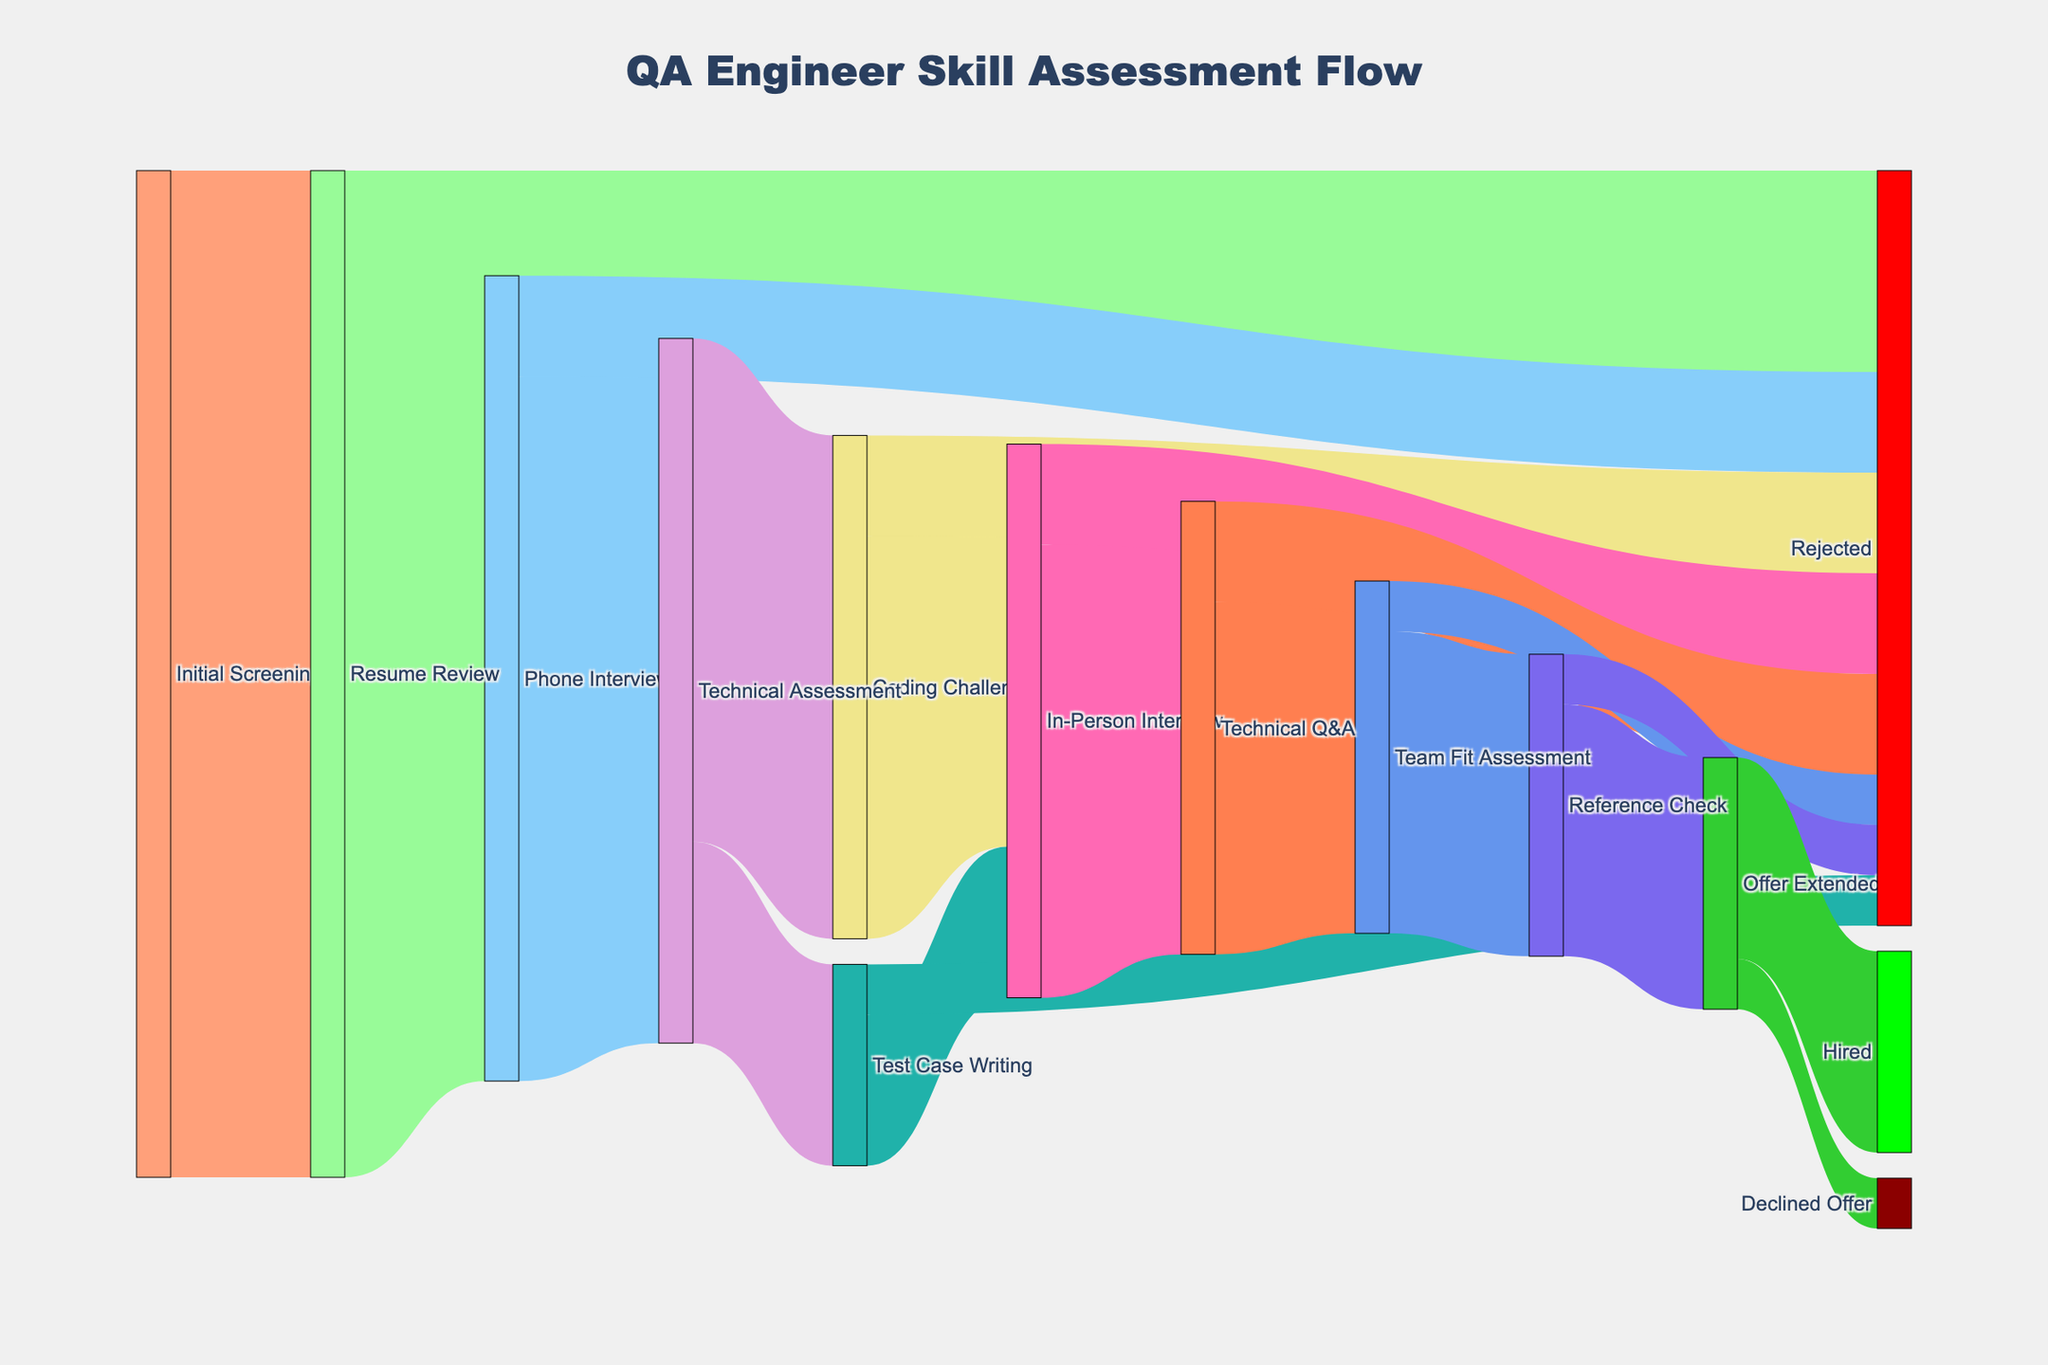What is the first step in the QA engineer skill assessment flow? The first step is depicted at the top of the diagram where the initial point originates.
Answer: Initial Screening How many candidates proceed to the Phone Interview stage? Follow the flow from Resume Review to Phone Interview and read the value.
Answer: 80 What is the total number of candidates rejected after the Phone Interview? Follow both rejection paths from the Phone Interview to its respective end points, add the values: 10 directly rejected + 10 rejected after Technical Assessment = 20.
Answer: 20 How many candidates make it to the In-Person Interview stage from the Technical Assessment? Sum the values from Coding Challenge to In-Person Interview and from Test Case Writing to In-Person Interview: 40 + 15 = 55.
Answer: 55 Which stage has the highest number of rejections? Identify all stages with a Rejected node and compare the values (Resume Review 20, Phone Interview 10, Technical Assessment 5 + 10, In-Person Interview 10, Technical Q&A 10, Team Fit Assessment 5, Reference Check 5).
Answer: Resume Review What percentage of candidates pass the Technical Q&A and proceed to the Team Fit Assessment? Calculate the percentage with the formula: (candidates proceeding to Team Fit Assessment / candidates evaluated in Technical Q&A) * 100 = (35 / 45) * 100 = ≈77.78%.
Answer: ≈77.78% Between 'Coding Challenge' and 'Test Case Writing', which route leads more candidates to the In-Person Interview? Compare the values: Coding Challenge to In-Person Interview is 40, Test Case Writing to In-Person Interview is 15.
Answer: Coding Challenge What is the total number of candidates who receive an offer? Sum the value of candidates who make it to the Offer Extended stage and are either hired or decline the offer: 20 + 5 = 25.
Answer: 25 How many pathways lead directly to rejection? Count each unique path terminating at a rejected node: Resume Review -> Rejected, Phone Interview -> Rejected, Coding Challenge -> Rejected, Test Case Writing -> Rejected, In-Person Interview -> Rejected, Technical Q&A -> Rejected, Team Fit Assessment -> Rejected, Reference Check -> Rejected.
Answer: 8 How many candidates were hired in total? Look at the final node before Hire and note its value.
Answer: 20 